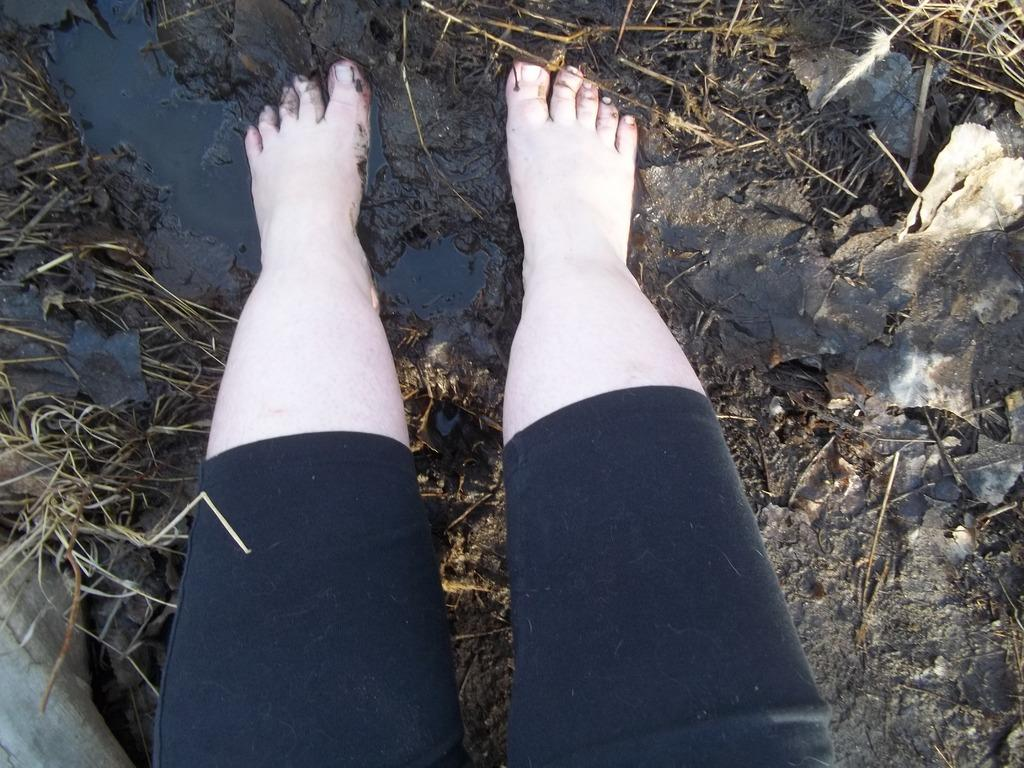What part of a person's body is visible in the image? There are a person's legs visible in the image. What is the surface on which the person's legs are placed? The person's legs are on the mud. What can be seen in the background of the image? There are sticks in the background of the image. Is there a basket hanging from the sticks in the image? There is no basket visible in the image; only sticks can be seen in the background. 